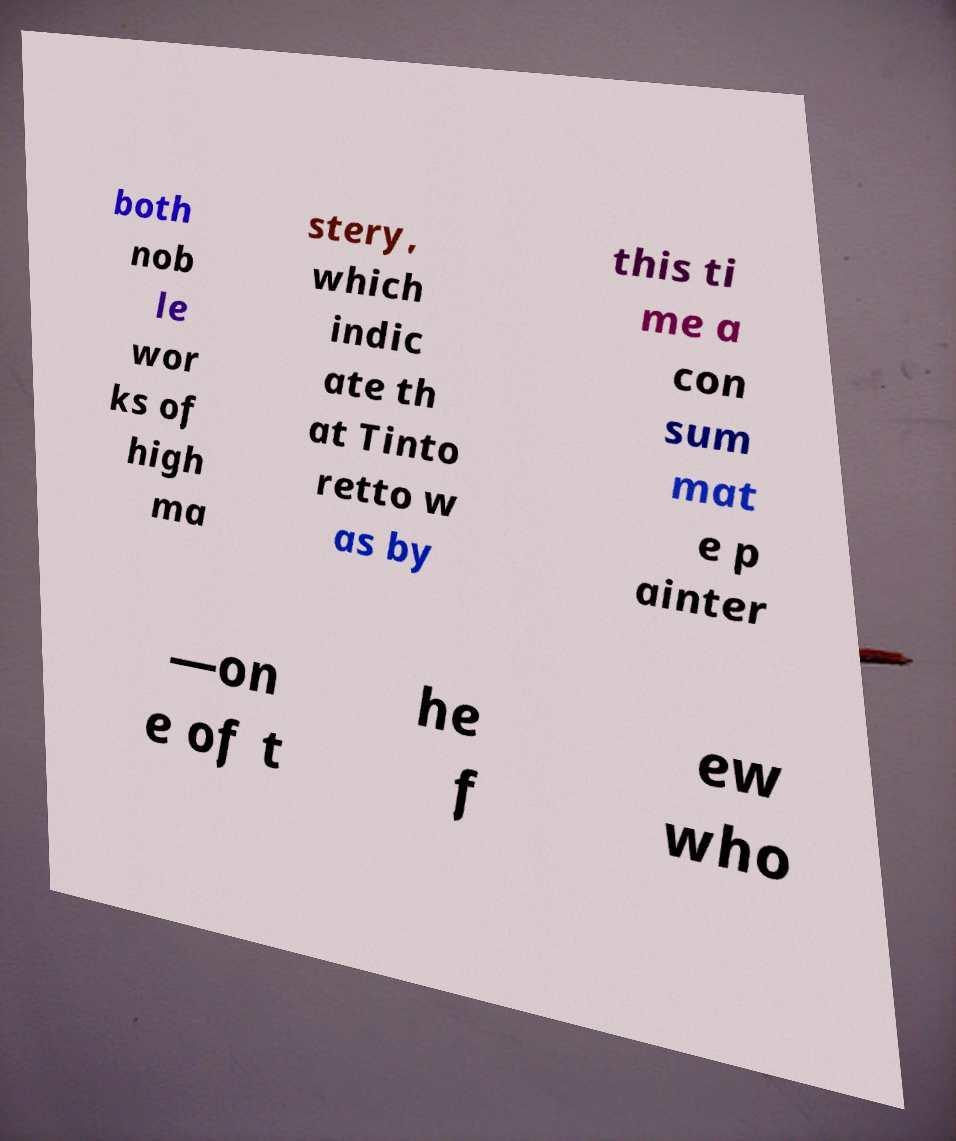There's text embedded in this image that I need extracted. Can you transcribe it verbatim? both nob le wor ks of high ma stery, which indic ate th at Tinto retto w as by this ti me a con sum mat e p ainter —on e of t he f ew who 